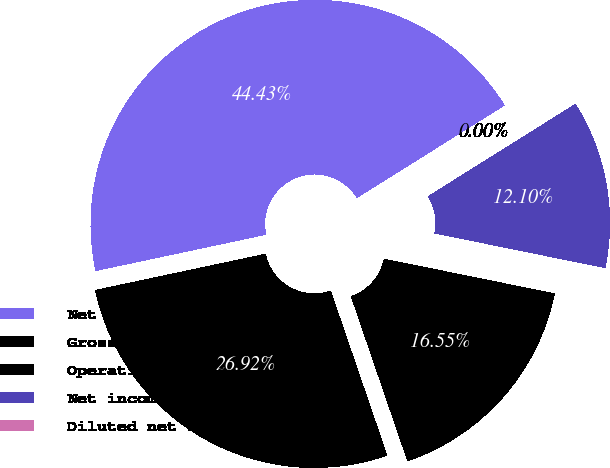<chart> <loc_0><loc_0><loc_500><loc_500><pie_chart><fcel>Net sales<fcel>Gross profit<fcel>Operating income<fcel>Net income<fcel>Diluted net income per common<nl><fcel>44.43%<fcel>26.92%<fcel>16.55%<fcel>12.1%<fcel>0.0%<nl></chart> 